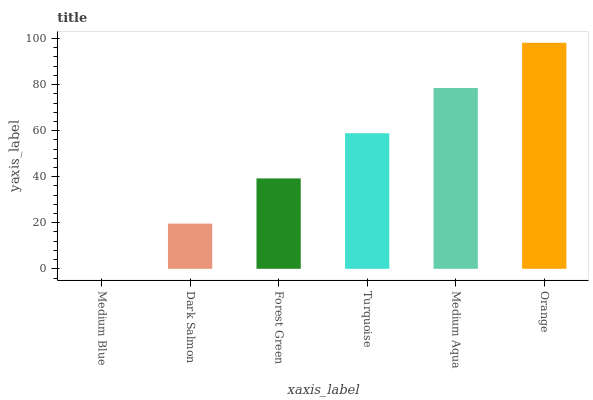Is Medium Blue the minimum?
Answer yes or no. Yes. Is Orange the maximum?
Answer yes or no. Yes. Is Dark Salmon the minimum?
Answer yes or no. No. Is Dark Salmon the maximum?
Answer yes or no. No. Is Dark Salmon greater than Medium Blue?
Answer yes or no. Yes. Is Medium Blue less than Dark Salmon?
Answer yes or no. Yes. Is Medium Blue greater than Dark Salmon?
Answer yes or no. No. Is Dark Salmon less than Medium Blue?
Answer yes or no. No. Is Turquoise the high median?
Answer yes or no. Yes. Is Forest Green the low median?
Answer yes or no. Yes. Is Orange the high median?
Answer yes or no. No. Is Medium Aqua the low median?
Answer yes or no. No. 